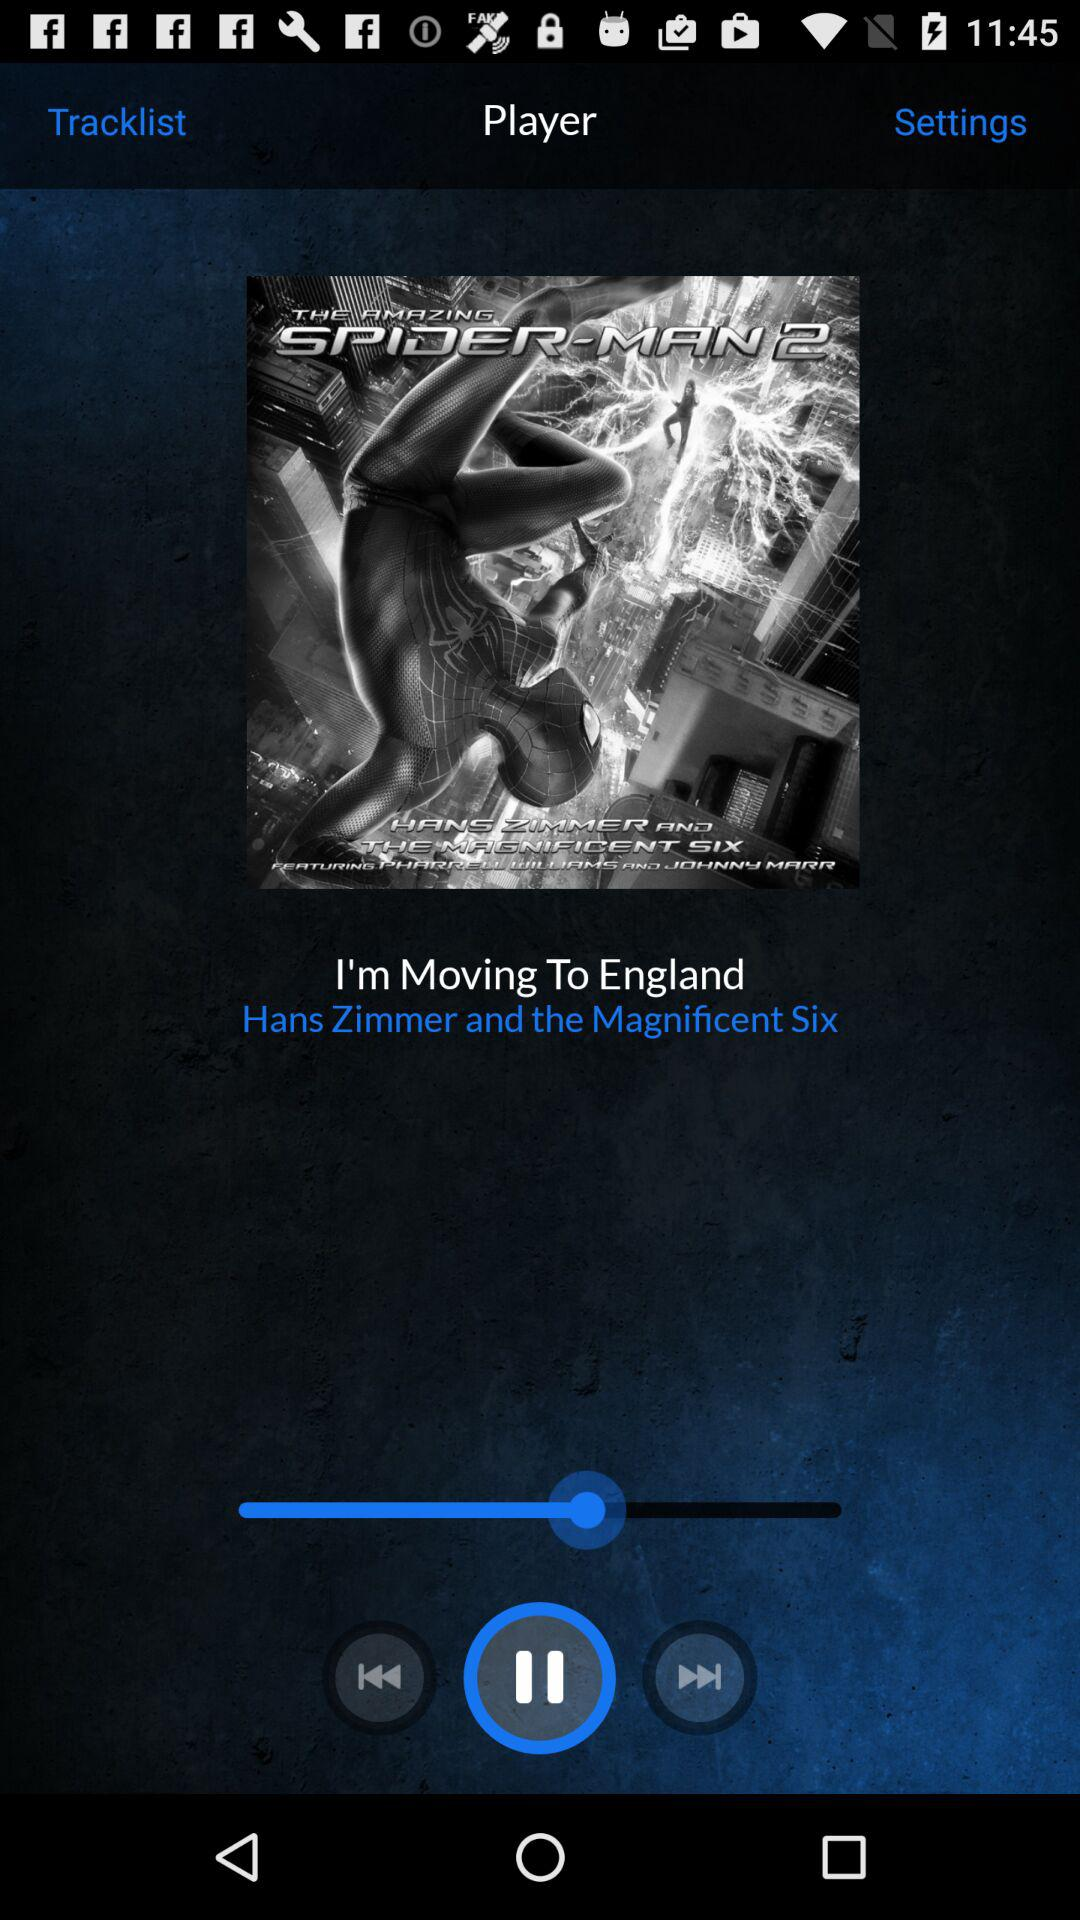What's the artist name of the song "I'm Moving To England"? The artist of the song "I'm Moving To England" is Hans Zimmer. 